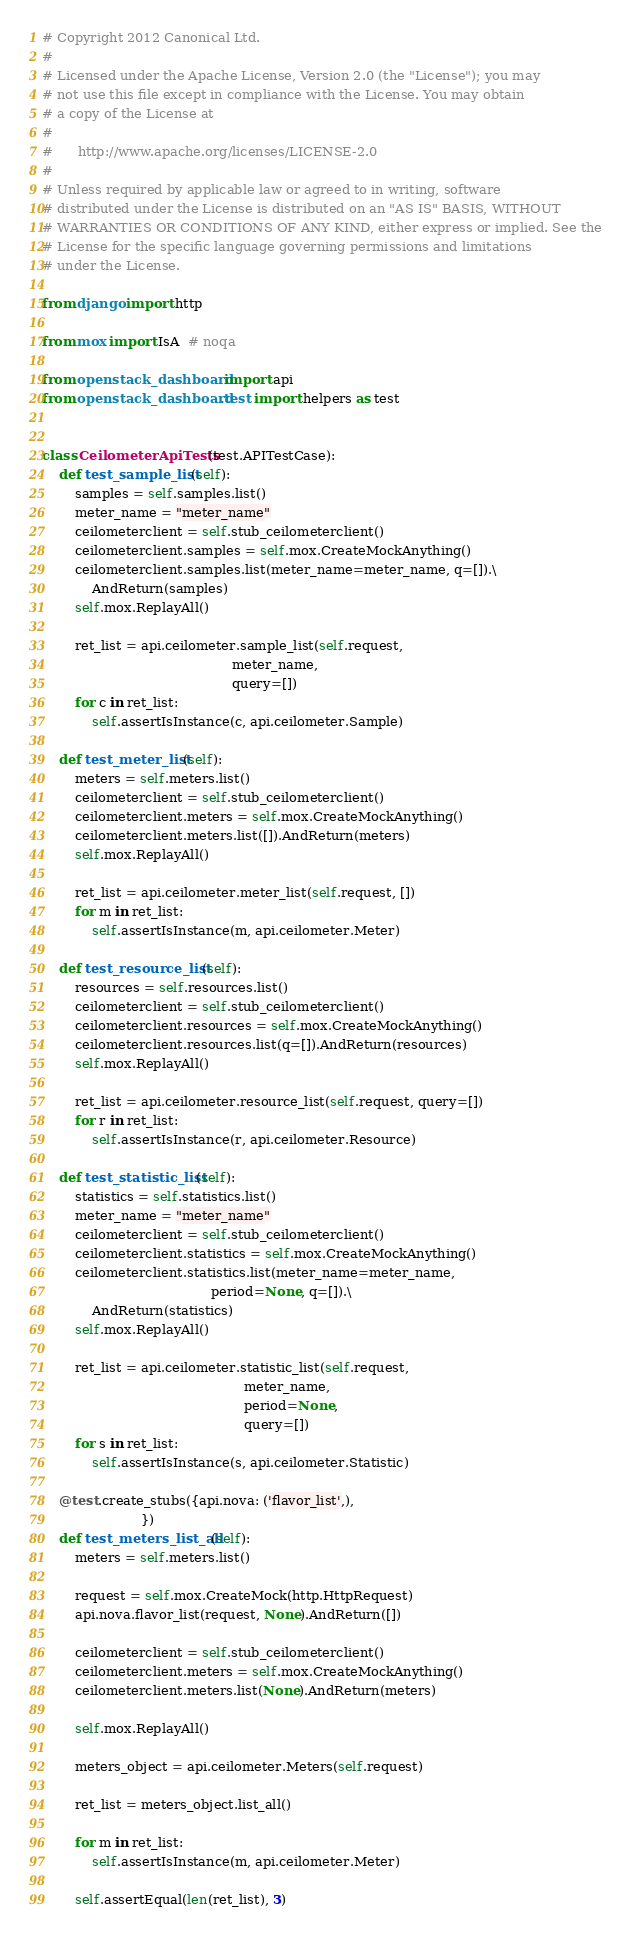Convert code to text. <code><loc_0><loc_0><loc_500><loc_500><_Python_># Copyright 2012 Canonical Ltd.
#
# Licensed under the Apache License, Version 2.0 (the "License"); you may
# not use this file except in compliance with the License. You may obtain
# a copy of the License at
#
#      http://www.apache.org/licenses/LICENSE-2.0
#
# Unless required by applicable law or agreed to in writing, software
# distributed under the License is distributed on an "AS IS" BASIS, WITHOUT
# WARRANTIES OR CONDITIONS OF ANY KIND, either express or implied. See the
# License for the specific language governing permissions and limitations
# under the License.

from django import http

from mox import IsA  # noqa

from openstack_dashboard import api
from openstack_dashboard.test import helpers as test


class CeilometerApiTests(test.APITestCase):
    def test_sample_list(self):
        samples = self.samples.list()
        meter_name = "meter_name"
        ceilometerclient = self.stub_ceilometerclient()
        ceilometerclient.samples = self.mox.CreateMockAnything()
        ceilometerclient.samples.list(meter_name=meter_name, q=[]).\
            AndReturn(samples)
        self.mox.ReplayAll()

        ret_list = api.ceilometer.sample_list(self.request,
                                              meter_name,
                                              query=[])
        for c in ret_list:
            self.assertIsInstance(c, api.ceilometer.Sample)

    def test_meter_list(self):
        meters = self.meters.list()
        ceilometerclient = self.stub_ceilometerclient()
        ceilometerclient.meters = self.mox.CreateMockAnything()
        ceilometerclient.meters.list([]).AndReturn(meters)
        self.mox.ReplayAll()

        ret_list = api.ceilometer.meter_list(self.request, [])
        for m in ret_list:
            self.assertIsInstance(m, api.ceilometer.Meter)

    def test_resource_list(self):
        resources = self.resources.list()
        ceilometerclient = self.stub_ceilometerclient()
        ceilometerclient.resources = self.mox.CreateMockAnything()
        ceilometerclient.resources.list(q=[]).AndReturn(resources)
        self.mox.ReplayAll()

        ret_list = api.ceilometer.resource_list(self.request, query=[])
        for r in ret_list:
            self.assertIsInstance(r, api.ceilometer.Resource)

    def test_statistic_list(self):
        statistics = self.statistics.list()
        meter_name = "meter_name"
        ceilometerclient = self.stub_ceilometerclient()
        ceilometerclient.statistics = self.mox.CreateMockAnything()
        ceilometerclient.statistics.list(meter_name=meter_name,
                                         period=None, q=[]).\
            AndReturn(statistics)
        self.mox.ReplayAll()

        ret_list = api.ceilometer.statistic_list(self.request,
                                                 meter_name,
                                                 period=None,
                                                 query=[])
        for s in ret_list:
            self.assertIsInstance(s, api.ceilometer.Statistic)

    @test.create_stubs({api.nova: ('flavor_list',),
                        })
    def test_meters_list_all(self):
        meters = self.meters.list()

        request = self.mox.CreateMock(http.HttpRequest)
        api.nova.flavor_list(request, None).AndReturn([])

        ceilometerclient = self.stub_ceilometerclient()
        ceilometerclient.meters = self.mox.CreateMockAnything()
        ceilometerclient.meters.list(None).AndReturn(meters)

        self.mox.ReplayAll()

        meters_object = api.ceilometer.Meters(self.request)

        ret_list = meters_object.list_all()

        for m in ret_list:
            self.assertIsInstance(m, api.ceilometer.Meter)

        self.assertEqual(len(ret_list), 3)
</code> 